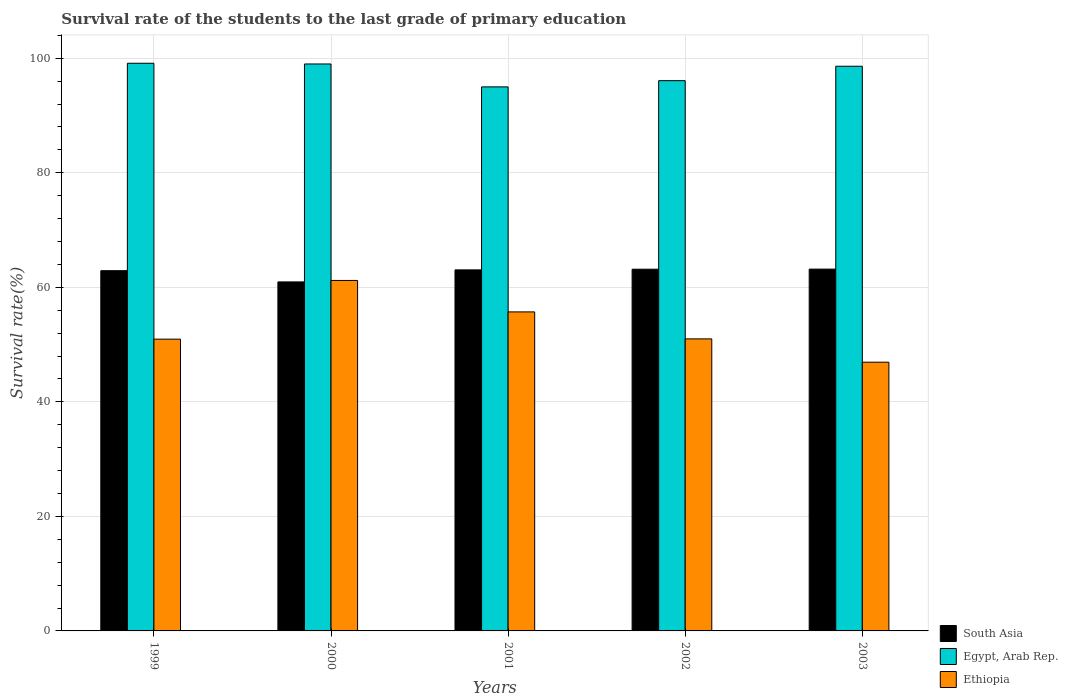Are the number of bars on each tick of the X-axis equal?
Your answer should be compact. Yes. How many bars are there on the 1st tick from the right?
Your response must be concise. 3. In how many cases, is the number of bars for a given year not equal to the number of legend labels?
Provide a short and direct response. 0. What is the survival rate of the students in Ethiopia in 2003?
Make the answer very short. 46.92. Across all years, what is the maximum survival rate of the students in Egypt, Arab Rep.?
Offer a terse response. 99.12. Across all years, what is the minimum survival rate of the students in Egypt, Arab Rep.?
Your answer should be compact. 95. In which year was the survival rate of the students in South Asia maximum?
Give a very brief answer. 2003. What is the total survival rate of the students in Ethiopia in the graph?
Make the answer very short. 265.78. What is the difference between the survival rate of the students in Egypt, Arab Rep. in 1999 and that in 2001?
Provide a succinct answer. 4.13. What is the difference between the survival rate of the students in Egypt, Arab Rep. in 2003 and the survival rate of the students in Ethiopia in 2001?
Offer a terse response. 42.9. What is the average survival rate of the students in South Asia per year?
Your response must be concise. 62.65. In the year 2003, what is the difference between the survival rate of the students in South Asia and survival rate of the students in Egypt, Arab Rep.?
Your answer should be compact. -35.42. What is the ratio of the survival rate of the students in South Asia in 2002 to that in 2003?
Your response must be concise. 1. Is the difference between the survival rate of the students in South Asia in 2000 and 2002 greater than the difference between the survival rate of the students in Egypt, Arab Rep. in 2000 and 2002?
Your answer should be compact. No. What is the difference between the highest and the second highest survival rate of the students in Ethiopia?
Offer a terse response. 5.49. What is the difference between the highest and the lowest survival rate of the students in Egypt, Arab Rep.?
Offer a very short reply. 4.13. What does the 2nd bar from the left in 1999 represents?
Provide a short and direct response. Egypt, Arab Rep. What does the 1st bar from the right in 1999 represents?
Make the answer very short. Ethiopia. Are all the bars in the graph horizontal?
Your response must be concise. No. How many years are there in the graph?
Your answer should be compact. 5. What is the difference between two consecutive major ticks on the Y-axis?
Offer a very short reply. 20. Does the graph contain any zero values?
Your answer should be very brief. No. Does the graph contain grids?
Your answer should be very brief. Yes. How many legend labels are there?
Keep it short and to the point. 3. How are the legend labels stacked?
Provide a short and direct response. Vertical. What is the title of the graph?
Your response must be concise. Survival rate of the students to the last grade of primary education. Does "Botswana" appear as one of the legend labels in the graph?
Provide a succinct answer. No. What is the label or title of the X-axis?
Offer a very short reply. Years. What is the label or title of the Y-axis?
Your answer should be compact. Survival rate(%). What is the Survival rate(%) in South Asia in 1999?
Provide a succinct answer. 62.9. What is the Survival rate(%) in Egypt, Arab Rep. in 1999?
Ensure brevity in your answer.  99.12. What is the Survival rate(%) in Ethiopia in 1999?
Keep it short and to the point. 50.95. What is the Survival rate(%) in South Asia in 2000?
Your answer should be compact. 60.94. What is the Survival rate(%) of Egypt, Arab Rep. in 2000?
Offer a very short reply. 99. What is the Survival rate(%) of Ethiopia in 2000?
Offer a very short reply. 61.2. What is the Survival rate(%) in South Asia in 2001?
Ensure brevity in your answer.  63.04. What is the Survival rate(%) of Egypt, Arab Rep. in 2001?
Provide a short and direct response. 95. What is the Survival rate(%) of Ethiopia in 2001?
Give a very brief answer. 55.71. What is the Survival rate(%) of South Asia in 2002?
Give a very brief answer. 63.16. What is the Survival rate(%) in Egypt, Arab Rep. in 2002?
Offer a terse response. 96.09. What is the Survival rate(%) of Ethiopia in 2002?
Offer a very short reply. 51. What is the Survival rate(%) in South Asia in 2003?
Provide a short and direct response. 63.18. What is the Survival rate(%) of Egypt, Arab Rep. in 2003?
Ensure brevity in your answer.  98.6. What is the Survival rate(%) in Ethiopia in 2003?
Give a very brief answer. 46.92. Across all years, what is the maximum Survival rate(%) of South Asia?
Your answer should be very brief. 63.18. Across all years, what is the maximum Survival rate(%) in Egypt, Arab Rep.?
Give a very brief answer. 99.12. Across all years, what is the maximum Survival rate(%) of Ethiopia?
Your answer should be compact. 61.2. Across all years, what is the minimum Survival rate(%) of South Asia?
Your response must be concise. 60.94. Across all years, what is the minimum Survival rate(%) in Egypt, Arab Rep.?
Your answer should be compact. 95. Across all years, what is the minimum Survival rate(%) in Ethiopia?
Offer a terse response. 46.92. What is the total Survival rate(%) of South Asia in the graph?
Your response must be concise. 313.23. What is the total Survival rate(%) in Egypt, Arab Rep. in the graph?
Keep it short and to the point. 487.81. What is the total Survival rate(%) of Ethiopia in the graph?
Your answer should be compact. 265.78. What is the difference between the Survival rate(%) in South Asia in 1999 and that in 2000?
Your answer should be compact. 1.96. What is the difference between the Survival rate(%) in Egypt, Arab Rep. in 1999 and that in 2000?
Ensure brevity in your answer.  0.13. What is the difference between the Survival rate(%) of Ethiopia in 1999 and that in 2000?
Ensure brevity in your answer.  -10.25. What is the difference between the Survival rate(%) of South Asia in 1999 and that in 2001?
Offer a terse response. -0.14. What is the difference between the Survival rate(%) of Egypt, Arab Rep. in 1999 and that in 2001?
Offer a very short reply. 4.13. What is the difference between the Survival rate(%) in Ethiopia in 1999 and that in 2001?
Provide a short and direct response. -4.76. What is the difference between the Survival rate(%) in South Asia in 1999 and that in 2002?
Provide a succinct answer. -0.26. What is the difference between the Survival rate(%) of Egypt, Arab Rep. in 1999 and that in 2002?
Your answer should be compact. 3.04. What is the difference between the Survival rate(%) of Ethiopia in 1999 and that in 2002?
Your answer should be compact. -0.05. What is the difference between the Survival rate(%) in South Asia in 1999 and that in 2003?
Your response must be concise. -0.27. What is the difference between the Survival rate(%) in Egypt, Arab Rep. in 1999 and that in 2003?
Your response must be concise. 0.52. What is the difference between the Survival rate(%) in Ethiopia in 1999 and that in 2003?
Provide a short and direct response. 4.03. What is the difference between the Survival rate(%) of South Asia in 2000 and that in 2001?
Make the answer very short. -2.1. What is the difference between the Survival rate(%) of Egypt, Arab Rep. in 2000 and that in 2001?
Your answer should be very brief. 4. What is the difference between the Survival rate(%) in Ethiopia in 2000 and that in 2001?
Provide a succinct answer. 5.49. What is the difference between the Survival rate(%) of South Asia in 2000 and that in 2002?
Ensure brevity in your answer.  -2.22. What is the difference between the Survival rate(%) in Egypt, Arab Rep. in 2000 and that in 2002?
Ensure brevity in your answer.  2.91. What is the difference between the Survival rate(%) in Ethiopia in 2000 and that in 2002?
Provide a short and direct response. 10.2. What is the difference between the Survival rate(%) in South Asia in 2000 and that in 2003?
Provide a succinct answer. -2.23. What is the difference between the Survival rate(%) in Egypt, Arab Rep. in 2000 and that in 2003?
Keep it short and to the point. 0.4. What is the difference between the Survival rate(%) of Ethiopia in 2000 and that in 2003?
Offer a terse response. 14.28. What is the difference between the Survival rate(%) in South Asia in 2001 and that in 2002?
Offer a terse response. -0.12. What is the difference between the Survival rate(%) in Egypt, Arab Rep. in 2001 and that in 2002?
Your answer should be compact. -1.09. What is the difference between the Survival rate(%) of Ethiopia in 2001 and that in 2002?
Provide a short and direct response. 4.71. What is the difference between the Survival rate(%) of South Asia in 2001 and that in 2003?
Your answer should be compact. -0.13. What is the difference between the Survival rate(%) in Egypt, Arab Rep. in 2001 and that in 2003?
Provide a short and direct response. -3.6. What is the difference between the Survival rate(%) of Ethiopia in 2001 and that in 2003?
Provide a short and direct response. 8.78. What is the difference between the Survival rate(%) in South Asia in 2002 and that in 2003?
Provide a short and direct response. -0.02. What is the difference between the Survival rate(%) in Egypt, Arab Rep. in 2002 and that in 2003?
Your answer should be very brief. -2.52. What is the difference between the Survival rate(%) of Ethiopia in 2002 and that in 2003?
Provide a short and direct response. 4.07. What is the difference between the Survival rate(%) in South Asia in 1999 and the Survival rate(%) in Egypt, Arab Rep. in 2000?
Offer a terse response. -36.09. What is the difference between the Survival rate(%) of South Asia in 1999 and the Survival rate(%) of Ethiopia in 2000?
Your answer should be very brief. 1.71. What is the difference between the Survival rate(%) of Egypt, Arab Rep. in 1999 and the Survival rate(%) of Ethiopia in 2000?
Your response must be concise. 37.92. What is the difference between the Survival rate(%) in South Asia in 1999 and the Survival rate(%) in Egypt, Arab Rep. in 2001?
Your answer should be very brief. -32.09. What is the difference between the Survival rate(%) of South Asia in 1999 and the Survival rate(%) of Ethiopia in 2001?
Offer a very short reply. 7.2. What is the difference between the Survival rate(%) in Egypt, Arab Rep. in 1999 and the Survival rate(%) in Ethiopia in 2001?
Offer a very short reply. 43.42. What is the difference between the Survival rate(%) of South Asia in 1999 and the Survival rate(%) of Egypt, Arab Rep. in 2002?
Keep it short and to the point. -33.18. What is the difference between the Survival rate(%) of South Asia in 1999 and the Survival rate(%) of Ethiopia in 2002?
Offer a very short reply. 11.91. What is the difference between the Survival rate(%) of Egypt, Arab Rep. in 1999 and the Survival rate(%) of Ethiopia in 2002?
Provide a succinct answer. 48.13. What is the difference between the Survival rate(%) in South Asia in 1999 and the Survival rate(%) in Egypt, Arab Rep. in 2003?
Your answer should be very brief. -35.7. What is the difference between the Survival rate(%) of South Asia in 1999 and the Survival rate(%) of Ethiopia in 2003?
Keep it short and to the point. 15.98. What is the difference between the Survival rate(%) in Egypt, Arab Rep. in 1999 and the Survival rate(%) in Ethiopia in 2003?
Keep it short and to the point. 52.2. What is the difference between the Survival rate(%) in South Asia in 2000 and the Survival rate(%) in Egypt, Arab Rep. in 2001?
Provide a succinct answer. -34.06. What is the difference between the Survival rate(%) in South Asia in 2000 and the Survival rate(%) in Ethiopia in 2001?
Provide a short and direct response. 5.24. What is the difference between the Survival rate(%) in Egypt, Arab Rep. in 2000 and the Survival rate(%) in Ethiopia in 2001?
Your answer should be very brief. 43.29. What is the difference between the Survival rate(%) of South Asia in 2000 and the Survival rate(%) of Egypt, Arab Rep. in 2002?
Make the answer very short. -35.14. What is the difference between the Survival rate(%) in South Asia in 2000 and the Survival rate(%) in Ethiopia in 2002?
Your answer should be very brief. 9.95. What is the difference between the Survival rate(%) of Egypt, Arab Rep. in 2000 and the Survival rate(%) of Ethiopia in 2002?
Give a very brief answer. 48. What is the difference between the Survival rate(%) in South Asia in 2000 and the Survival rate(%) in Egypt, Arab Rep. in 2003?
Offer a very short reply. -37.66. What is the difference between the Survival rate(%) of South Asia in 2000 and the Survival rate(%) of Ethiopia in 2003?
Keep it short and to the point. 14.02. What is the difference between the Survival rate(%) of Egypt, Arab Rep. in 2000 and the Survival rate(%) of Ethiopia in 2003?
Provide a short and direct response. 52.07. What is the difference between the Survival rate(%) in South Asia in 2001 and the Survival rate(%) in Egypt, Arab Rep. in 2002?
Offer a terse response. -33.04. What is the difference between the Survival rate(%) in South Asia in 2001 and the Survival rate(%) in Ethiopia in 2002?
Offer a terse response. 12.05. What is the difference between the Survival rate(%) of Egypt, Arab Rep. in 2001 and the Survival rate(%) of Ethiopia in 2002?
Keep it short and to the point. 44. What is the difference between the Survival rate(%) in South Asia in 2001 and the Survival rate(%) in Egypt, Arab Rep. in 2003?
Ensure brevity in your answer.  -35.56. What is the difference between the Survival rate(%) of South Asia in 2001 and the Survival rate(%) of Ethiopia in 2003?
Give a very brief answer. 16.12. What is the difference between the Survival rate(%) of Egypt, Arab Rep. in 2001 and the Survival rate(%) of Ethiopia in 2003?
Ensure brevity in your answer.  48.08. What is the difference between the Survival rate(%) of South Asia in 2002 and the Survival rate(%) of Egypt, Arab Rep. in 2003?
Provide a succinct answer. -35.44. What is the difference between the Survival rate(%) of South Asia in 2002 and the Survival rate(%) of Ethiopia in 2003?
Your response must be concise. 16.24. What is the difference between the Survival rate(%) of Egypt, Arab Rep. in 2002 and the Survival rate(%) of Ethiopia in 2003?
Provide a short and direct response. 49.16. What is the average Survival rate(%) in South Asia per year?
Ensure brevity in your answer.  62.65. What is the average Survival rate(%) in Egypt, Arab Rep. per year?
Make the answer very short. 97.56. What is the average Survival rate(%) in Ethiopia per year?
Ensure brevity in your answer.  53.16. In the year 1999, what is the difference between the Survival rate(%) in South Asia and Survival rate(%) in Egypt, Arab Rep.?
Provide a succinct answer. -36.22. In the year 1999, what is the difference between the Survival rate(%) of South Asia and Survival rate(%) of Ethiopia?
Ensure brevity in your answer.  11.96. In the year 1999, what is the difference between the Survival rate(%) in Egypt, Arab Rep. and Survival rate(%) in Ethiopia?
Provide a short and direct response. 48.18. In the year 2000, what is the difference between the Survival rate(%) in South Asia and Survival rate(%) in Egypt, Arab Rep.?
Provide a succinct answer. -38.05. In the year 2000, what is the difference between the Survival rate(%) of South Asia and Survival rate(%) of Ethiopia?
Offer a terse response. -0.26. In the year 2000, what is the difference between the Survival rate(%) in Egypt, Arab Rep. and Survival rate(%) in Ethiopia?
Offer a terse response. 37.8. In the year 2001, what is the difference between the Survival rate(%) in South Asia and Survival rate(%) in Egypt, Arab Rep.?
Keep it short and to the point. -31.95. In the year 2001, what is the difference between the Survival rate(%) in South Asia and Survival rate(%) in Ethiopia?
Offer a very short reply. 7.34. In the year 2001, what is the difference between the Survival rate(%) in Egypt, Arab Rep. and Survival rate(%) in Ethiopia?
Your answer should be very brief. 39.29. In the year 2002, what is the difference between the Survival rate(%) in South Asia and Survival rate(%) in Egypt, Arab Rep.?
Offer a very short reply. -32.92. In the year 2002, what is the difference between the Survival rate(%) in South Asia and Survival rate(%) in Ethiopia?
Keep it short and to the point. 12.17. In the year 2002, what is the difference between the Survival rate(%) of Egypt, Arab Rep. and Survival rate(%) of Ethiopia?
Your answer should be compact. 45.09. In the year 2003, what is the difference between the Survival rate(%) of South Asia and Survival rate(%) of Egypt, Arab Rep.?
Make the answer very short. -35.42. In the year 2003, what is the difference between the Survival rate(%) in South Asia and Survival rate(%) in Ethiopia?
Ensure brevity in your answer.  16.25. In the year 2003, what is the difference between the Survival rate(%) of Egypt, Arab Rep. and Survival rate(%) of Ethiopia?
Ensure brevity in your answer.  51.68. What is the ratio of the Survival rate(%) in South Asia in 1999 to that in 2000?
Your response must be concise. 1.03. What is the ratio of the Survival rate(%) of Egypt, Arab Rep. in 1999 to that in 2000?
Make the answer very short. 1. What is the ratio of the Survival rate(%) in Ethiopia in 1999 to that in 2000?
Ensure brevity in your answer.  0.83. What is the ratio of the Survival rate(%) of South Asia in 1999 to that in 2001?
Provide a short and direct response. 1. What is the ratio of the Survival rate(%) of Egypt, Arab Rep. in 1999 to that in 2001?
Keep it short and to the point. 1.04. What is the ratio of the Survival rate(%) of Ethiopia in 1999 to that in 2001?
Offer a terse response. 0.91. What is the ratio of the Survival rate(%) of Egypt, Arab Rep. in 1999 to that in 2002?
Make the answer very short. 1.03. What is the ratio of the Survival rate(%) in Egypt, Arab Rep. in 1999 to that in 2003?
Your answer should be compact. 1.01. What is the ratio of the Survival rate(%) in Ethiopia in 1999 to that in 2003?
Provide a succinct answer. 1.09. What is the ratio of the Survival rate(%) of South Asia in 2000 to that in 2001?
Offer a terse response. 0.97. What is the ratio of the Survival rate(%) of Egypt, Arab Rep. in 2000 to that in 2001?
Keep it short and to the point. 1.04. What is the ratio of the Survival rate(%) of Ethiopia in 2000 to that in 2001?
Your answer should be very brief. 1.1. What is the ratio of the Survival rate(%) in South Asia in 2000 to that in 2002?
Your answer should be compact. 0.96. What is the ratio of the Survival rate(%) of Egypt, Arab Rep. in 2000 to that in 2002?
Make the answer very short. 1.03. What is the ratio of the Survival rate(%) of Ethiopia in 2000 to that in 2002?
Provide a short and direct response. 1.2. What is the ratio of the Survival rate(%) in South Asia in 2000 to that in 2003?
Offer a terse response. 0.96. What is the ratio of the Survival rate(%) of Ethiopia in 2000 to that in 2003?
Your answer should be very brief. 1.3. What is the ratio of the Survival rate(%) of South Asia in 2001 to that in 2002?
Provide a short and direct response. 1. What is the ratio of the Survival rate(%) of Egypt, Arab Rep. in 2001 to that in 2002?
Make the answer very short. 0.99. What is the ratio of the Survival rate(%) of Ethiopia in 2001 to that in 2002?
Offer a very short reply. 1.09. What is the ratio of the Survival rate(%) in South Asia in 2001 to that in 2003?
Provide a succinct answer. 1. What is the ratio of the Survival rate(%) of Egypt, Arab Rep. in 2001 to that in 2003?
Ensure brevity in your answer.  0.96. What is the ratio of the Survival rate(%) of Ethiopia in 2001 to that in 2003?
Your answer should be compact. 1.19. What is the ratio of the Survival rate(%) of South Asia in 2002 to that in 2003?
Keep it short and to the point. 1. What is the ratio of the Survival rate(%) of Egypt, Arab Rep. in 2002 to that in 2003?
Make the answer very short. 0.97. What is the ratio of the Survival rate(%) of Ethiopia in 2002 to that in 2003?
Provide a short and direct response. 1.09. What is the difference between the highest and the second highest Survival rate(%) in South Asia?
Provide a succinct answer. 0.02. What is the difference between the highest and the second highest Survival rate(%) of Egypt, Arab Rep.?
Keep it short and to the point. 0.13. What is the difference between the highest and the second highest Survival rate(%) of Ethiopia?
Your answer should be very brief. 5.49. What is the difference between the highest and the lowest Survival rate(%) in South Asia?
Offer a very short reply. 2.23. What is the difference between the highest and the lowest Survival rate(%) in Egypt, Arab Rep.?
Provide a short and direct response. 4.13. What is the difference between the highest and the lowest Survival rate(%) of Ethiopia?
Provide a succinct answer. 14.28. 